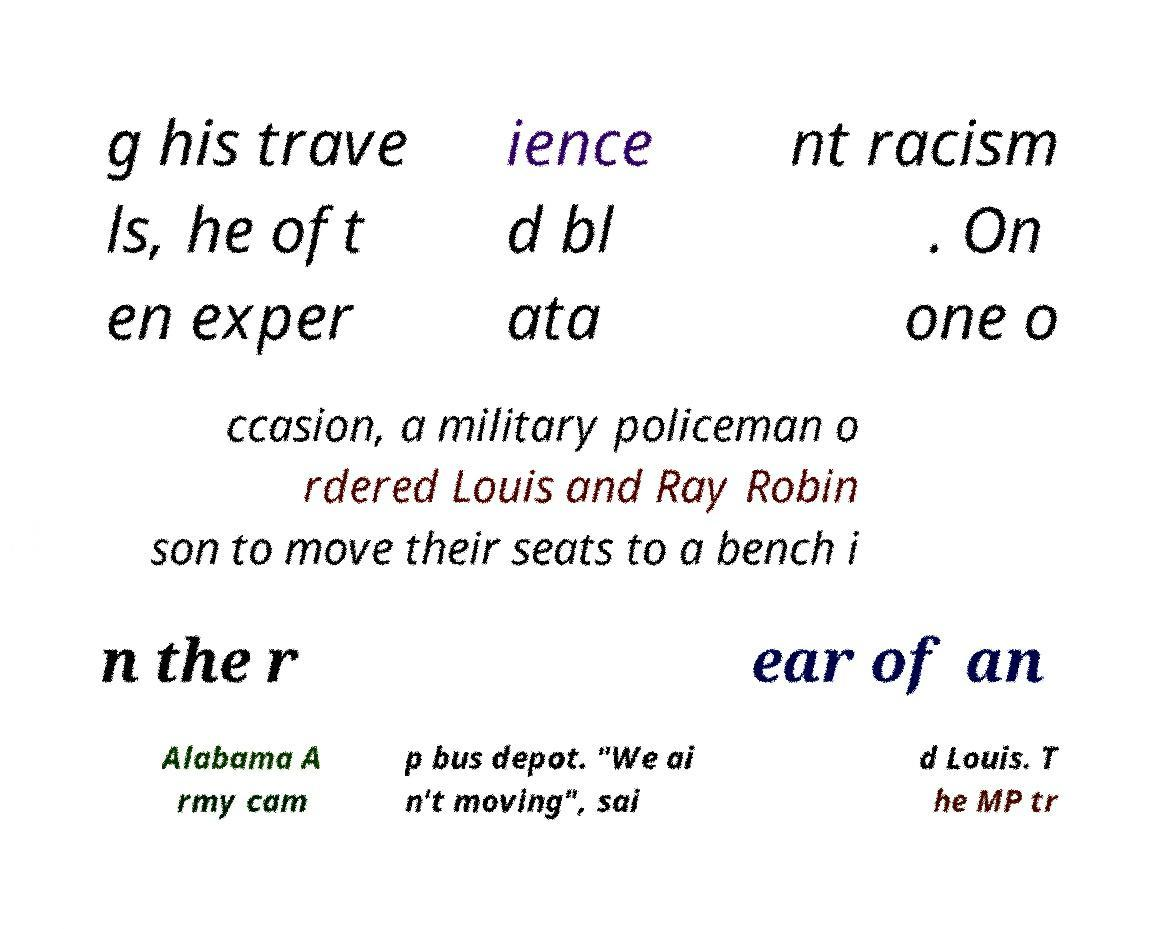Can you accurately transcribe the text from the provided image for me? g his trave ls, he oft en exper ience d bl ata nt racism . On one o ccasion, a military policeman o rdered Louis and Ray Robin son to move their seats to a bench i n the r ear of an Alabama A rmy cam p bus depot. "We ai n't moving", sai d Louis. T he MP tr 